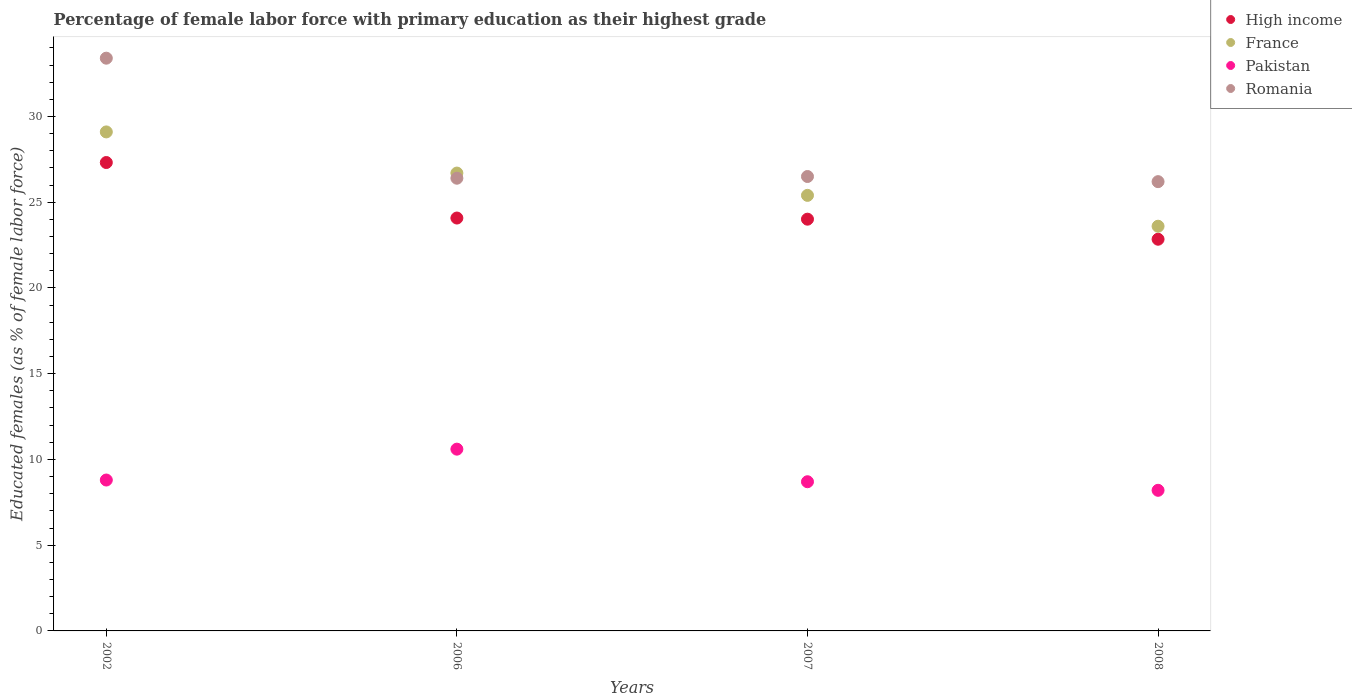What is the percentage of female labor force with primary education in France in 2002?
Your response must be concise. 29.1. Across all years, what is the maximum percentage of female labor force with primary education in Romania?
Your answer should be very brief. 33.4. Across all years, what is the minimum percentage of female labor force with primary education in Pakistan?
Provide a succinct answer. 8.2. In which year was the percentage of female labor force with primary education in Pakistan minimum?
Your response must be concise. 2008. What is the total percentage of female labor force with primary education in Pakistan in the graph?
Offer a very short reply. 36.3. What is the difference between the percentage of female labor force with primary education in Romania in 2007 and that in 2008?
Your answer should be compact. 0.3. What is the difference between the percentage of female labor force with primary education in Romania in 2002 and the percentage of female labor force with primary education in France in 2007?
Provide a succinct answer. 8. What is the average percentage of female labor force with primary education in Pakistan per year?
Your response must be concise. 9.08. In the year 2006, what is the difference between the percentage of female labor force with primary education in Romania and percentage of female labor force with primary education in High income?
Offer a terse response. 2.32. In how many years, is the percentage of female labor force with primary education in Pakistan greater than 31 %?
Provide a succinct answer. 0. What is the ratio of the percentage of female labor force with primary education in Romania in 2002 to that in 2006?
Offer a terse response. 1.27. Is the percentage of female labor force with primary education in Romania in 2007 less than that in 2008?
Make the answer very short. No. Is the difference between the percentage of female labor force with primary education in Romania in 2006 and 2008 greater than the difference between the percentage of female labor force with primary education in High income in 2006 and 2008?
Offer a very short reply. No. What is the difference between the highest and the second highest percentage of female labor force with primary education in Pakistan?
Give a very brief answer. 1.8. What is the difference between the highest and the lowest percentage of female labor force with primary education in Pakistan?
Your answer should be very brief. 2.4. In how many years, is the percentage of female labor force with primary education in Romania greater than the average percentage of female labor force with primary education in Romania taken over all years?
Make the answer very short. 1. Is it the case that in every year, the sum of the percentage of female labor force with primary education in France and percentage of female labor force with primary education in Pakistan  is greater than the sum of percentage of female labor force with primary education in Romania and percentage of female labor force with primary education in High income?
Make the answer very short. No. Does the percentage of female labor force with primary education in Romania monotonically increase over the years?
Give a very brief answer. No. How many dotlines are there?
Make the answer very short. 4. How many years are there in the graph?
Provide a short and direct response. 4. What is the difference between two consecutive major ticks on the Y-axis?
Offer a very short reply. 5. Are the values on the major ticks of Y-axis written in scientific E-notation?
Give a very brief answer. No. Does the graph contain any zero values?
Provide a succinct answer. No. How many legend labels are there?
Provide a short and direct response. 4. What is the title of the graph?
Offer a very short reply. Percentage of female labor force with primary education as their highest grade. What is the label or title of the X-axis?
Give a very brief answer. Years. What is the label or title of the Y-axis?
Make the answer very short. Educated females (as % of female labor force). What is the Educated females (as % of female labor force) in High income in 2002?
Provide a short and direct response. 27.32. What is the Educated females (as % of female labor force) in France in 2002?
Your response must be concise. 29.1. What is the Educated females (as % of female labor force) of Pakistan in 2002?
Give a very brief answer. 8.8. What is the Educated females (as % of female labor force) of Romania in 2002?
Your answer should be compact. 33.4. What is the Educated females (as % of female labor force) in High income in 2006?
Keep it short and to the point. 24.08. What is the Educated females (as % of female labor force) in France in 2006?
Your answer should be very brief. 26.7. What is the Educated females (as % of female labor force) of Pakistan in 2006?
Give a very brief answer. 10.6. What is the Educated females (as % of female labor force) in Romania in 2006?
Make the answer very short. 26.4. What is the Educated females (as % of female labor force) of High income in 2007?
Your answer should be very brief. 24.01. What is the Educated females (as % of female labor force) of France in 2007?
Provide a succinct answer. 25.4. What is the Educated females (as % of female labor force) of Pakistan in 2007?
Give a very brief answer. 8.7. What is the Educated females (as % of female labor force) of Romania in 2007?
Offer a very short reply. 26.5. What is the Educated females (as % of female labor force) in High income in 2008?
Give a very brief answer. 22.84. What is the Educated females (as % of female labor force) of France in 2008?
Give a very brief answer. 23.6. What is the Educated females (as % of female labor force) in Pakistan in 2008?
Provide a short and direct response. 8.2. What is the Educated females (as % of female labor force) of Romania in 2008?
Offer a very short reply. 26.2. Across all years, what is the maximum Educated females (as % of female labor force) in High income?
Your response must be concise. 27.32. Across all years, what is the maximum Educated females (as % of female labor force) in France?
Offer a terse response. 29.1. Across all years, what is the maximum Educated females (as % of female labor force) in Pakistan?
Ensure brevity in your answer.  10.6. Across all years, what is the maximum Educated females (as % of female labor force) in Romania?
Make the answer very short. 33.4. Across all years, what is the minimum Educated females (as % of female labor force) of High income?
Provide a short and direct response. 22.84. Across all years, what is the minimum Educated females (as % of female labor force) of France?
Ensure brevity in your answer.  23.6. Across all years, what is the minimum Educated females (as % of female labor force) of Pakistan?
Your answer should be compact. 8.2. Across all years, what is the minimum Educated females (as % of female labor force) of Romania?
Your answer should be very brief. 26.2. What is the total Educated females (as % of female labor force) in High income in the graph?
Offer a terse response. 98.25. What is the total Educated females (as % of female labor force) in France in the graph?
Offer a terse response. 104.8. What is the total Educated females (as % of female labor force) in Pakistan in the graph?
Offer a very short reply. 36.3. What is the total Educated females (as % of female labor force) in Romania in the graph?
Your answer should be compact. 112.5. What is the difference between the Educated females (as % of female labor force) of High income in 2002 and that in 2006?
Keep it short and to the point. 3.24. What is the difference between the Educated females (as % of female labor force) in Romania in 2002 and that in 2006?
Your response must be concise. 7. What is the difference between the Educated females (as % of female labor force) of High income in 2002 and that in 2007?
Offer a terse response. 3.3. What is the difference between the Educated females (as % of female labor force) of France in 2002 and that in 2007?
Give a very brief answer. 3.7. What is the difference between the Educated females (as % of female labor force) of Romania in 2002 and that in 2007?
Give a very brief answer. 6.9. What is the difference between the Educated females (as % of female labor force) in High income in 2002 and that in 2008?
Give a very brief answer. 4.47. What is the difference between the Educated females (as % of female labor force) of France in 2002 and that in 2008?
Provide a short and direct response. 5.5. What is the difference between the Educated females (as % of female labor force) in Pakistan in 2002 and that in 2008?
Your answer should be very brief. 0.6. What is the difference between the Educated females (as % of female labor force) in Romania in 2002 and that in 2008?
Your answer should be very brief. 7.2. What is the difference between the Educated females (as % of female labor force) in High income in 2006 and that in 2007?
Your response must be concise. 0.07. What is the difference between the Educated females (as % of female labor force) in Pakistan in 2006 and that in 2007?
Your response must be concise. 1.9. What is the difference between the Educated females (as % of female labor force) in High income in 2006 and that in 2008?
Keep it short and to the point. 1.24. What is the difference between the Educated females (as % of female labor force) of France in 2006 and that in 2008?
Provide a succinct answer. 3.1. What is the difference between the Educated females (as % of female labor force) in Romania in 2006 and that in 2008?
Offer a very short reply. 0.2. What is the difference between the Educated females (as % of female labor force) of High income in 2007 and that in 2008?
Keep it short and to the point. 1.17. What is the difference between the Educated females (as % of female labor force) of Romania in 2007 and that in 2008?
Your answer should be very brief. 0.3. What is the difference between the Educated females (as % of female labor force) of High income in 2002 and the Educated females (as % of female labor force) of France in 2006?
Provide a succinct answer. 0.61. What is the difference between the Educated females (as % of female labor force) in High income in 2002 and the Educated females (as % of female labor force) in Pakistan in 2006?
Keep it short and to the point. 16.71. What is the difference between the Educated females (as % of female labor force) of High income in 2002 and the Educated females (as % of female labor force) of Romania in 2006?
Your answer should be very brief. 0.92. What is the difference between the Educated females (as % of female labor force) in France in 2002 and the Educated females (as % of female labor force) in Pakistan in 2006?
Keep it short and to the point. 18.5. What is the difference between the Educated females (as % of female labor force) of Pakistan in 2002 and the Educated females (as % of female labor force) of Romania in 2006?
Your answer should be compact. -17.6. What is the difference between the Educated females (as % of female labor force) in High income in 2002 and the Educated females (as % of female labor force) in France in 2007?
Keep it short and to the point. 1.92. What is the difference between the Educated females (as % of female labor force) of High income in 2002 and the Educated females (as % of female labor force) of Pakistan in 2007?
Provide a succinct answer. 18.61. What is the difference between the Educated females (as % of female labor force) of High income in 2002 and the Educated females (as % of female labor force) of Romania in 2007?
Give a very brief answer. 0.81. What is the difference between the Educated females (as % of female labor force) in France in 2002 and the Educated females (as % of female labor force) in Pakistan in 2007?
Offer a terse response. 20.4. What is the difference between the Educated females (as % of female labor force) in Pakistan in 2002 and the Educated females (as % of female labor force) in Romania in 2007?
Offer a terse response. -17.7. What is the difference between the Educated females (as % of female labor force) in High income in 2002 and the Educated females (as % of female labor force) in France in 2008?
Keep it short and to the point. 3.71. What is the difference between the Educated females (as % of female labor force) of High income in 2002 and the Educated females (as % of female labor force) of Pakistan in 2008?
Ensure brevity in your answer.  19.11. What is the difference between the Educated females (as % of female labor force) of High income in 2002 and the Educated females (as % of female labor force) of Romania in 2008?
Make the answer very short. 1.11. What is the difference between the Educated females (as % of female labor force) in France in 2002 and the Educated females (as % of female labor force) in Pakistan in 2008?
Your answer should be very brief. 20.9. What is the difference between the Educated females (as % of female labor force) of Pakistan in 2002 and the Educated females (as % of female labor force) of Romania in 2008?
Ensure brevity in your answer.  -17.4. What is the difference between the Educated females (as % of female labor force) in High income in 2006 and the Educated females (as % of female labor force) in France in 2007?
Give a very brief answer. -1.32. What is the difference between the Educated females (as % of female labor force) in High income in 2006 and the Educated females (as % of female labor force) in Pakistan in 2007?
Offer a terse response. 15.38. What is the difference between the Educated females (as % of female labor force) of High income in 2006 and the Educated females (as % of female labor force) of Romania in 2007?
Provide a short and direct response. -2.42. What is the difference between the Educated females (as % of female labor force) in France in 2006 and the Educated females (as % of female labor force) in Romania in 2007?
Offer a terse response. 0.2. What is the difference between the Educated females (as % of female labor force) of Pakistan in 2006 and the Educated females (as % of female labor force) of Romania in 2007?
Provide a short and direct response. -15.9. What is the difference between the Educated females (as % of female labor force) in High income in 2006 and the Educated females (as % of female labor force) in France in 2008?
Keep it short and to the point. 0.48. What is the difference between the Educated females (as % of female labor force) of High income in 2006 and the Educated females (as % of female labor force) of Pakistan in 2008?
Your answer should be compact. 15.88. What is the difference between the Educated females (as % of female labor force) of High income in 2006 and the Educated females (as % of female labor force) of Romania in 2008?
Provide a short and direct response. -2.12. What is the difference between the Educated females (as % of female labor force) in France in 2006 and the Educated females (as % of female labor force) in Romania in 2008?
Make the answer very short. 0.5. What is the difference between the Educated females (as % of female labor force) in Pakistan in 2006 and the Educated females (as % of female labor force) in Romania in 2008?
Your answer should be compact. -15.6. What is the difference between the Educated females (as % of female labor force) in High income in 2007 and the Educated females (as % of female labor force) in France in 2008?
Give a very brief answer. 0.41. What is the difference between the Educated females (as % of female labor force) of High income in 2007 and the Educated females (as % of female labor force) of Pakistan in 2008?
Provide a short and direct response. 15.81. What is the difference between the Educated females (as % of female labor force) in High income in 2007 and the Educated females (as % of female labor force) in Romania in 2008?
Offer a very short reply. -2.19. What is the difference between the Educated females (as % of female labor force) of Pakistan in 2007 and the Educated females (as % of female labor force) of Romania in 2008?
Provide a succinct answer. -17.5. What is the average Educated females (as % of female labor force) of High income per year?
Keep it short and to the point. 24.56. What is the average Educated females (as % of female labor force) of France per year?
Offer a very short reply. 26.2. What is the average Educated females (as % of female labor force) in Pakistan per year?
Make the answer very short. 9.07. What is the average Educated females (as % of female labor force) of Romania per year?
Ensure brevity in your answer.  28.12. In the year 2002, what is the difference between the Educated females (as % of female labor force) of High income and Educated females (as % of female labor force) of France?
Your answer should be compact. -1.78. In the year 2002, what is the difference between the Educated females (as % of female labor force) of High income and Educated females (as % of female labor force) of Pakistan?
Offer a terse response. 18.52. In the year 2002, what is the difference between the Educated females (as % of female labor force) in High income and Educated females (as % of female labor force) in Romania?
Provide a short and direct response. -6.08. In the year 2002, what is the difference between the Educated females (as % of female labor force) of France and Educated females (as % of female labor force) of Pakistan?
Provide a short and direct response. 20.3. In the year 2002, what is the difference between the Educated females (as % of female labor force) in Pakistan and Educated females (as % of female labor force) in Romania?
Your answer should be very brief. -24.6. In the year 2006, what is the difference between the Educated females (as % of female labor force) of High income and Educated females (as % of female labor force) of France?
Your response must be concise. -2.62. In the year 2006, what is the difference between the Educated females (as % of female labor force) in High income and Educated females (as % of female labor force) in Pakistan?
Provide a short and direct response. 13.48. In the year 2006, what is the difference between the Educated females (as % of female labor force) of High income and Educated females (as % of female labor force) of Romania?
Keep it short and to the point. -2.32. In the year 2006, what is the difference between the Educated females (as % of female labor force) of Pakistan and Educated females (as % of female labor force) of Romania?
Your response must be concise. -15.8. In the year 2007, what is the difference between the Educated females (as % of female labor force) in High income and Educated females (as % of female labor force) in France?
Offer a terse response. -1.39. In the year 2007, what is the difference between the Educated females (as % of female labor force) in High income and Educated females (as % of female labor force) in Pakistan?
Ensure brevity in your answer.  15.31. In the year 2007, what is the difference between the Educated females (as % of female labor force) in High income and Educated females (as % of female labor force) in Romania?
Your response must be concise. -2.49. In the year 2007, what is the difference between the Educated females (as % of female labor force) of France and Educated females (as % of female labor force) of Romania?
Your answer should be very brief. -1.1. In the year 2007, what is the difference between the Educated females (as % of female labor force) in Pakistan and Educated females (as % of female labor force) in Romania?
Provide a short and direct response. -17.8. In the year 2008, what is the difference between the Educated females (as % of female labor force) in High income and Educated females (as % of female labor force) in France?
Offer a very short reply. -0.76. In the year 2008, what is the difference between the Educated females (as % of female labor force) of High income and Educated females (as % of female labor force) of Pakistan?
Provide a succinct answer. 14.64. In the year 2008, what is the difference between the Educated females (as % of female labor force) of High income and Educated females (as % of female labor force) of Romania?
Give a very brief answer. -3.36. In the year 2008, what is the difference between the Educated females (as % of female labor force) in France and Educated females (as % of female labor force) in Pakistan?
Your response must be concise. 15.4. In the year 2008, what is the difference between the Educated females (as % of female labor force) of France and Educated females (as % of female labor force) of Romania?
Offer a very short reply. -2.6. What is the ratio of the Educated females (as % of female labor force) in High income in 2002 to that in 2006?
Keep it short and to the point. 1.13. What is the ratio of the Educated females (as % of female labor force) of France in 2002 to that in 2006?
Make the answer very short. 1.09. What is the ratio of the Educated females (as % of female labor force) in Pakistan in 2002 to that in 2006?
Ensure brevity in your answer.  0.83. What is the ratio of the Educated females (as % of female labor force) of Romania in 2002 to that in 2006?
Make the answer very short. 1.27. What is the ratio of the Educated females (as % of female labor force) of High income in 2002 to that in 2007?
Give a very brief answer. 1.14. What is the ratio of the Educated females (as % of female labor force) in France in 2002 to that in 2007?
Keep it short and to the point. 1.15. What is the ratio of the Educated females (as % of female labor force) of Pakistan in 2002 to that in 2007?
Offer a very short reply. 1.01. What is the ratio of the Educated females (as % of female labor force) in Romania in 2002 to that in 2007?
Your response must be concise. 1.26. What is the ratio of the Educated females (as % of female labor force) of High income in 2002 to that in 2008?
Keep it short and to the point. 1.2. What is the ratio of the Educated females (as % of female labor force) in France in 2002 to that in 2008?
Ensure brevity in your answer.  1.23. What is the ratio of the Educated females (as % of female labor force) of Pakistan in 2002 to that in 2008?
Give a very brief answer. 1.07. What is the ratio of the Educated females (as % of female labor force) in Romania in 2002 to that in 2008?
Give a very brief answer. 1.27. What is the ratio of the Educated females (as % of female labor force) of France in 2006 to that in 2007?
Ensure brevity in your answer.  1.05. What is the ratio of the Educated females (as % of female labor force) of Pakistan in 2006 to that in 2007?
Ensure brevity in your answer.  1.22. What is the ratio of the Educated females (as % of female labor force) of Romania in 2006 to that in 2007?
Your response must be concise. 1. What is the ratio of the Educated females (as % of female labor force) of High income in 2006 to that in 2008?
Give a very brief answer. 1.05. What is the ratio of the Educated females (as % of female labor force) of France in 2006 to that in 2008?
Your response must be concise. 1.13. What is the ratio of the Educated females (as % of female labor force) of Pakistan in 2006 to that in 2008?
Your response must be concise. 1.29. What is the ratio of the Educated females (as % of female labor force) of Romania in 2006 to that in 2008?
Provide a succinct answer. 1.01. What is the ratio of the Educated females (as % of female labor force) of High income in 2007 to that in 2008?
Give a very brief answer. 1.05. What is the ratio of the Educated females (as % of female labor force) in France in 2007 to that in 2008?
Give a very brief answer. 1.08. What is the ratio of the Educated females (as % of female labor force) in Pakistan in 2007 to that in 2008?
Make the answer very short. 1.06. What is the ratio of the Educated females (as % of female labor force) in Romania in 2007 to that in 2008?
Make the answer very short. 1.01. What is the difference between the highest and the second highest Educated females (as % of female labor force) of High income?
Your response must be concise. 3.24. What is the difference between the highest and the second highest Educated females (as % of female labor force) in Pakistan?
Your answer should be very brief. 1.8. What is the difference between the highest and the lowest Educated females (as % of female labor force) in High income?
Your answer should be compact. 4.47. What is the difference between the highest and the lowest Educated females (as % of female labor force) in France?
Provide a succinct answer. 5.5. What is the difference between the highest and the lowest Educated females (as % of female labor force) of Pakistan?
Your answer should be compact. 2.4. 